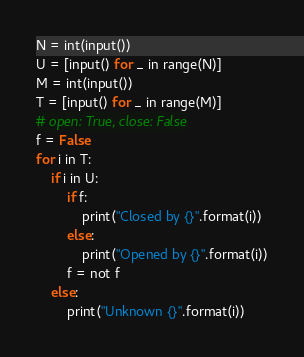Convert code to text. <code><loc_0><loc_0><loc_500><loc_500><_Python_>N = int(input())
U = [input() for _ in range(N)]
M = int(input())
T = [input() for _ in range(M)]
# open: True, close: False
f = False
for i in T:
    if i in U:
        if f:
            print("Closed by {}".format(i))
        else:
            print("Opened by {}".format(i))
        f = not f
    else:
        print("Unknown {}".format(i))

</code> 